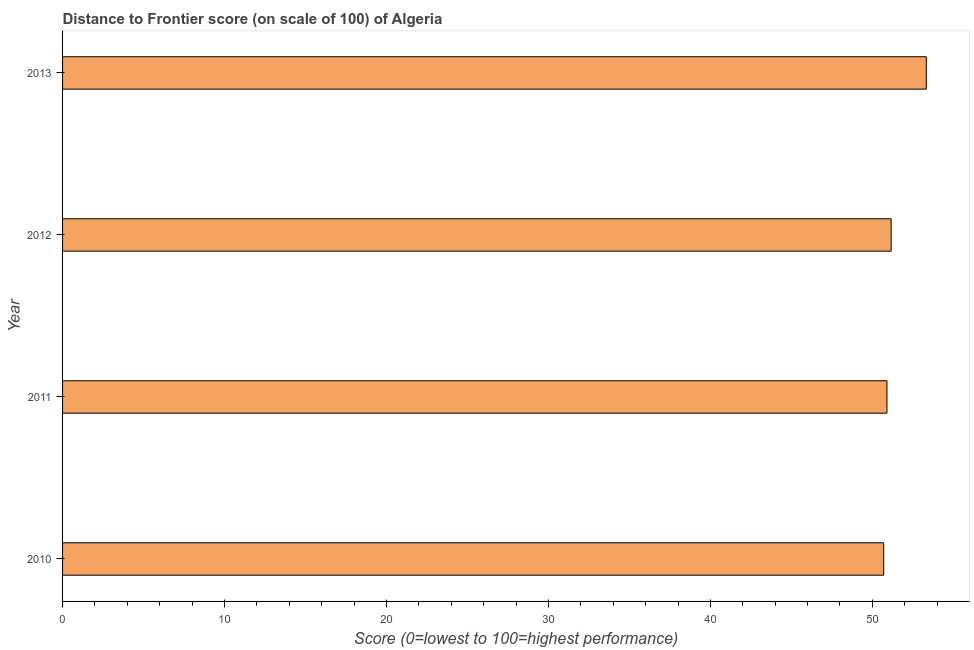What is the title of the graph?
Make the answer very short. Distance to Frontier score (on scale of 100) of Algeria. What is the label or title of the X-axis?
Make the answer very short. Score (0=lowest to 100=highest performance). What is the label or title of the Y-axis?
Your response must be concise. Year. What is the distance to frontier score in 2013?
Your answer should be compact. 53.33. Across all years, what is the maximum distance to frontier score?
Offer a terse response. 53.33. Across all years, what is the minimum distance to frontier score?
Offer a terse response. 50.7. In which year was the distance to frontier score maximum?
Your response must be concise. 2013. In which year was the distance to frontier score minimum?
Provide a short and direct response. 2010. What is the sum of the distance to frontier score?
Provide a succinct answer. 206.09. What is the difference between the distance to frontier score in 2011 and 2013?
Ensure brevity in your answer.  -2.43. What is the average distance to frontier score per year?
Keep it short and to the point. 51.52. What is the median distance to frontier score?
Ensure brevity in your answer.  51.03. What is the ratio of the distance to frontier score in 2011 to that in 2013?
Provide a short and direct response. 0.95. Is the difference between the distance to frontier score in 2010 and 2013 greater than the difference between any two years?
Make the answer very short. Yes. What is the difference between the highest and the second highest distance to frontier score?
Give a very brief answer. 2.17. Is the sum of the distance to frontier score in 2012 and 2013 greater than the maximum distance to frontier score across all years?
Your answer should be very brief. Yes. What is the difference between the highest and the lowest distance to frontier score?
Provide a short and direct response. 2.63. How many years are there in the graph?
Ensure brevity in your answer.  4. What is the Score (0=lowest to 100=highest performance) in 2010?
Offer a terse response. 50.7. What is the Score (0=lowest to 100=highest performance) in 2011?
Give a very brief answer. 50.9. What is the Score (0=lowest to 100=highest performance) of 2012?
Keep it short and to the point. 51.16. What is the Score (0=lowest to 100=highest performance) of 2013?
Provide a succinct answer. 53.33. What is the difference between the Score (0=lowest to 100=highest performance) in 2010 and 2012?
Offer a very short reply. -0.46. What is the difference between the Score (0=lowest to 100=highest performance) in 2010 and 2013?
Your response must be concise. -2.63. What is the difference between the Score (0=lowest to 100=highest performance) in 2011 and 2012?
Ensure brevity in your answer.  -0.26. What is the difference between the Score (0=lowest to 100=highest performance) in 2011 and 2013?
Provide a succinct answer. -2.43. What is the difference between the Score (0=lowest to 100=highest performance) in 2012 and 2013?
Make the answer very short. -2.17. What is the ratio of the Score (0=lowest to 100=highest performance) in 2010 to that in 2013?
Keep it short and to the point. 0.95. What is the ratio of the Score (0=lowest to 100=highest performance) in 2011 to that in 2012?
Provide a short and direct response. 0.99. What is the ratio of the Score (0=lowest to 100=highest performance) in 2011 to that in 2013?
Keep it short and to the point. 0.95. What is the ratio of the Score (0=lowest to 100=highest performance) in 2012 to that in 2013?
Provide a succinct answer. 0.96. 